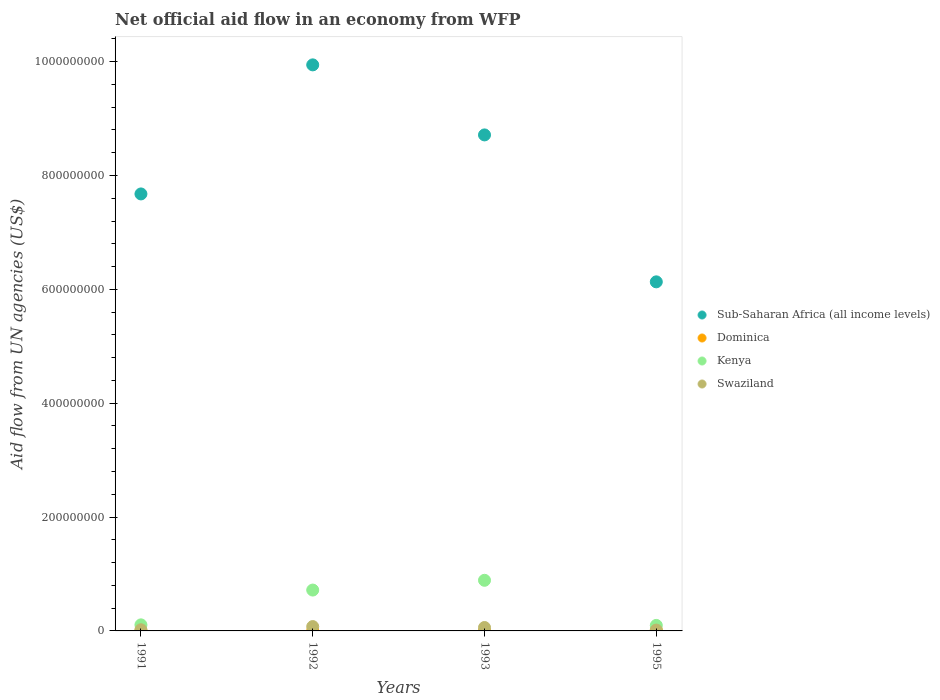How many different coloured dotlines are there?
Your response must be concise. 4. What is the net official aid flow in Dominica in 1993?
Your response must be concise. 2.20e+05. Across all years, what is the maximum net official aid flow in Swaziland?
Keep it short and to the point. 7.62e+06. Across all years, what is the minimum net official aid flow in Dominica?
Your response must be concise. 2.10e+05. In which year was the net official aid flow in Dominica maximum?
Provide a succinct answer. 1995. What is the total net official aid flow in Dominica in the graph?
Keep it short and to the point. 2.00e+06. What is the difference between the net official aid flow in Swaziland in 1992 and that in 1995?
Ensure brevity in your answer.  6.12e+06. What is the difference between the net official aid flow in Kenya in 1993 and the net official aid flow in Dominica in 1991?
Keep it short and to the point. 8.86e+07. What is the average net official aid flow in Swaziland per year?
Provide a succinct answer. 4.29e+06. In the year 1995, what is the difference between the net official aid flow in Sub-Saharan Africa (all income levels) and net official aid flow in Kenya?
Give a very brief answer. 6.03e+08. In how many years, is the net official aid flow in Dominica greater than 400000000 US$?
Your response must be concise. 0. What is the ratio of the net official aid flow in Sub-Saharan Africa (all income levels) in 1991 to that in 1992?
Offer a terse response. 0.77. What is the difference between the highest and the second highest net official aid flow in Dominica?
Your answer should be very brief. 1.01e+06. What is the difference between the highest and the lowest net official aid flow in Sub-Saharan Africa (all income levels)?
Provide a short and direct response. 3.81e+08. In how many years, is the net official aid flow in Kenya greater than the average net official aid flow in Kenya taken over all years?
Your answer should be very brief. 2. Is it the case that in every year, the sum of the net official aid flow in Dominica and net official aid flow in Sub-Saharan Africa (all income levels)  is greater than the sum of net official aid flow in Swaziland and net official aid flow in Kenya?
Offer a terse response. Yes. Is the net official aid flow in Dominica strictly greater than the net official aid flow in Sub-Saharan Africa (all income levels) over the years?
Offer a terse response. No. Is the net official aid flow in Sub-Saharan Africa (all income levels) strictly less than the net official aid flow in Swaziland over the years?
Provide a short and direct response. No. How many dotlines are there?
Give a very brief answer. 4. Does the graph contain any zero values?
Provide a succinct answer. No. How are the legend labels stacked?
Ensure brevity in your answer.  Vertical. What is the title of the graph?
Provide a succinct answer. Net official aid flow in an economy from WFP. What is the label or title of the Y-axis?
Offer a terse response. Aid flow from UN agencies (US$). What is the Aid flow from UN agencies (US$) in Sub-Saharan Africa (all income levels) in 1991?
Your answer should be compact. 7.68e+08. What is the Aid flow from UN agencies (US$) in Kenya in 1991?
Ensure brevity in your answer.  1.06e+07. What is the Aid flow from UN agencies (US$) of Swaziland in 1991?
Your response must be concise. 2.06e+06. What is the Aid flow from UN agencies (US$) in Sub-Saharan Africa (all income levels) in 1992?
Your answer should be compact. 9.94e+08. What is the Aid flow from UN agencies (US$) in Kenya in 1992?
Provide a short and direct response. 7.18e+07. What is the Aid flow from UN agencies (US$) of Swaziland in 1992?
Your answer should be compact. 7.62e+06. What is the Aid flow from UN agencies (US$) of Sub-Saharan Africa (all income levels) in 1993?
Your response must be concise. 8.71e+08. What is the Aid flow from UN agencies (US$) of Dominica in 1993?
Provide a short and direct response. 2.20e+05. What is the Aid flow from UN agencies (US$) of Kenya in 1993?
Keep it short and to the point. 8.89e+07. What is the Aid flow from UN agencies (US$) in Swaziland in 1993?
Ensure brevity in your answer.  5.99e+06. What is the Aid flow from UN agencies (US$) of Sub-Saharan Africa (all income levels) in 1995?
Provide a short and direct response. 6.13e+08. What is the Aid flow from UN agencies (US$) in Dominica in 1995?
Provide a succinct answer. 1.29e+06. What is the Aid flow from UN agencies (US$) in Kenya in 1995?
Keep it short and to the point. 9.68e+06. What is the Aid flow from UN agencies (US$) in Swaziland in 1995?
Your answer should be very brief. 1.50e+06. Across all years, what is the maximum Aid flow from UN agencies (US$) of Sub-Saharan Africa (all income levels)?
Keep it short and to the point. 9.94e+08. Across all years, what is the maximum Aid flow from UN agencies (US$) in Dominica?
Ensure brevity in your answer.  1.29e+06. Across all years, what is the maximum Aid flow from UN agencies (US$) in Kenya?
Offer a very short reply. 8.89e+07. Across all years, what is the maximum Aid flow from UN agencies (US$) of Swaziland?
Provide a succinct answer. 7.62e+06. Across all years, what is the minimum Aid flow from UN agencies (US$) of Sub-Saharan Africa (all income levels)?
Make the answer very short. 6.13e+08. Across all years, what is the minimum Aid flow from UN agencies (US$) of Dominica?
Give a very brief answer. 2.10e+05. Across all years, what is the minimum Aid flow from UN agencies (US$) in Kenya?
Your answer should be compact. 9.68e+06. Across all years, what is the minimum Aid flow from UN agencies (US$) in Swaziland?
Offer a very short reply. 1.50e+06. What is the total Aid flow from UN agencies (US$) in Sub-Saharan Africa (all income levels) in the graph?
Your answer should be very brief. 3.25e+09. What is the total Aid flow from UN agencies (US$) in Dominica in the graph?
Offer a terse response. 2.00e+06. What is the total Aid flow from UN agencies (US$) in Kenya in the graph?
Offer a terse response. 1.81e+08. What is the total Aid flow from UN agencies (US$) in Swaziland in the graph?
Give a very brief answer. 1.72e+07. What is the difference between the Aid flow from UN agencies (US$) of Sub-Saharan Africa (all income levels) in 1991 and that in 1992?
Your answer should be compact. -2.27e+08. What is the difference between the Aid flow from UN agencies (US$) of Dominica in 1991 and that in 1992?
Keep it short and to the point. 7.00e+04. What is the difference between the Aid flow from UN agencies (US$) of Kenya in 1991 and that in 1992?
Make the answer very short. -6.11e+07. What is the difference between the Aid flow from UN agencies (US$) in Swaziland in 1991 and that in 1992?
Your response must be concise. -5.56e+06. What is the difference between the Aid flow from UN agencies (US$) in Sub-Saharan Africa (all income levels) in 1991 and that in 1993?
Your answer should be compact. -1.04e+08. What is the difference between the Aid flow from UN agencies (US$) in Dominica in 1991 and that in 1993?
Provide a succinct answer. 6.00e+04. What is the difference between the Aid flow from UN agencies (US$) in Kenya in 1991 and that in 1993?
Offer a terse response. -7.83e+07. What is the difference between the Aid flow from UN agencies (US$) of Swaziland in 1991 and that in 1993?
Offer a terse response. -3.93e+06. What is the difference between the Aid flow from UN agencies (US$) of Sub-Saharan Africa (all income levels) in 1991 and that in 1995?
Give a very brief answer. 1.54e+08. What is the difference between the Aid flow from UN agencies (US$) of Dominica in 1991 and that in 1995?
Offer a terse response. -1.01e+06. What is the difference between the Aid flow from UN agencies (US$) in Kenya in 1991 and that in 1995?
Offer a very short reply. 9.60e+05. What is the difference between the Aid flow from UN agencies (US$) in Swaziland in 1991 and that in 1995?
Provide a succinct answer. 5.60e+05. What is the difference between the Aid flow from UN agencies (US$) in Sub-Saharan Africa (all income levels) in 1992 and that in 1993?
Ensure brevity in your answer.  1.23e+08. What is the difference between the Aid flow from UN agencies (US$) of Dominica in 1992 and that in 1993?
Your answer should be very brief. -10000. What is the difference between the Aid flow from UN agencies (US$) in Kenya in 1992 and that in 1993?
Your response must be concise. -1.72e+07. What is the difference between the Aid flow from UN agencies (US$) of Swaziland in 1992 and that in 1993?
Ensure brevity in your answer.  1.63e+06. What is the difference between the Aid flow from UN agencies (US$) of Sub-Saharan Africa (all income levels) in 1992 and that in 1995?
Your answer should be very brief. 3.81e+08. What is the difference between the Aid flow from UN agencies (US$) of Dominica in 1992 and that in 1995?
Give a very brief answer. -1.08e+06. What is the difference between the Aid flow from UN agencies (US$) in Kenya in 1992 and that in 1995?
Offer a terse response. 6.21e+07. What is the difference between the Aid flow from UN agencies (US$) in Swaziland in 1992 and that in 1995?
Offer a terse response. 6.12e+06. What is the difference between the Aid flow from UN agencies (US$) of Sub-Saharan Africa (all income levels) in 1993 and that in 1995?
Provide a short and direct response. 2.58e+08. What is the difference between the Aid flow from UN agencies (US$) of Dominica in 1993 and that in 1995?
Ensure brevity in your answer.  -1.07e+06. What is the difference between the Aid flow from UN agencies (US$) of Kenya in 1993 and that in 1995?
Keep it short and to the point. 7.92e+07. What is the difference between the Aid flow from UN agencies (US$) of Swaziland in 1993 and that in 1995?
Your answer should be very brief. 4.49e+06. What is the difference between the Aid flow from UN agencies (US$) in Sub-Saharan Africa (all income levels) in 1991 and the Aid flow from UN agencies (US$) in Dominica in 1992?
Make the answer very short. 7.67e+08. What is the difference between the Aid flow from UN agencies (US$) of Sub-Saharan Africa (all income levels) in 1991 and the Aid flow from UN agencies (US$) of Kenya in 1992?
Offer a very short reply. 6.96e+08. What is the difference between the Aid flow from UN agencies (US$) in Sub-Saharan Africa (all income levels) in 1991 and the Aid flow from UN agencies (US$) in Swaziland in 1992?
Make the answer very short. 7.60e+08. What is the difference between the Aid flow from UN agencies (US$) in Dominica in 1991 and the Aid flow from UN agencies (US$) in Kenya in 1992?
Your response must be concise. -7.15e+07. What is the difference between the Aid flow from UN agencies (US$) of Dominica in 1991 and the Aid flow from UN agencies (US$) of Swaziland in 1992?
Make the answer very short. -7.34e+06. What is the difference between the Aid flow from UN agencies (US$) of Kenya in 1991 and the Aid flow from UN agencies (US$) of Swaziland in 1992?
Offer a terse response. 3.02e+06. What is the difference between the Aid flow from UN agencies (US$) of Sub-Saharan Africa (all income levels) in 1991 and the Aid flow from UN agencies (US$) of Dominica in 1993?
Provide a succinct answer. 7.67e+08. What is the difference between the Aid flow from UN agencies (US$) of Sub-Saharan Africa (all income levels) in 1991 and the Aid flow from UN agencies (US$) of Kenya in 1993?
Your response must be concise. 6.79e+08. What is the difference between the Aid flow from UN agencies (US$) in Sub-Saharan Africa (all income levels) in 1991 and the Aid flow from UN agencies (US$) in Swaziland in 1993?
Ensure brevity in your answer.  7.62e+08. What is the difference between the Aid flow from UN agencies (US$) in Dominica in 1991 and the Aid flow from UN agencies (US$) in Kenya in 1993?
Your answer should be compact. -8.86e+07. What is the difference between the Aid flow from UN agencies (US$) in Dominica in 1991 and the Aid flow from UN agencies (US$) in Swaziland in 1993?
Keep it short and to the point. -5.71e+06. What is the difference between the Aid flow from UN agencies (US$) in Kenya in 1991 and the Aid flow from UN agencies (US$) in Swaziland in 1993?
Provide a succinct answer. 4.65e+06. What is the difference between the Aid flow from UN agencies (US$) of Sub-Saharan Africa (all income levels) in 1991 and the Aid flow from UN agencies (US$) of Dominica in 1995?
Make the answer very short. 7.66e+08. What is the difference between the Aid flow from UN agencies (US$) of Sub-Saharan Africa (all income levels) in 1991 and the Aid flow from UN agencies (US$) of Kenya in 1995?
Ensure brevity in your answer.  7.58e+08. What is the difference between the Aid flow from UN agencies (US$) in Sub-Saharan Africa (all income levels) in 1991 and the Aid flow from UN agencies (US$) in Swaziland in 1995?
Make the answer very short. 7.66e+08. What is the difference between the Aid flow from UN agencies (US$) of Dominica in 1991 and the Aid flow from UN agencies (US$) of Kenya in 1995?
Your response must be concise. -9.40e+06. What is the difference between the Aid flow from UN agencies (US$) of Dominica in 1991 and the Aid flow from UN agencies (US$) of Swaziland in 1995?
Provide a short and direct response. -1.22e+06. What is the difference between the Aid flow from UN agencies (US$) in Kenya in 1991 and the Aid flow from UN agencies (US$) in Swaziland in 1995?
Provide a succinct answer. 9.14e+06. What is the difference between the Aid flow from UN agencies (US$) of Sub-Saharan Africa (all income levels) in 1992 and the Aid flow from UN agencies (US$) of Dominica in 1993?
Your response must be concise. 9.94e+08. What is the difference between the Aid flow from UN agencies (US$) of Sub-Saharan Africa (all income levels) in 1992 and the Aid flow from UN agencies (US$) of Kenya in 1993?
Your answer should be very brief. 9.05e+08. What is the difference between the Aid flow from UN agencies (US$) in Sub-Saharan Africa (all income levels) in 1992 and the Aid flow from UN agencies (US$) in Swaziland in 1993?
Your answer should be compact. 9.88e+08. What is the difference between the Aid flow from UN agencies (US$) of Dominica in 1992 and the Aid flow from UN agencies (US$) of Kenya in 1993?
Your response must be concise. -8.87e+07. What is the difference between the Aid flow from UN agencies (US$) in Dominica in 1992 and the Aid flow from UN agencies (US$) in Swaziland in 1993?
Your answer should be very brief. -5.78e+06. What is the difference between the Aid flow from UN agencies (US$) in Kenya in 1992 and the Aid flow from UN agencies (US$) in Swaziland in 1993?
Your response must be concise. 6.58e+07. What is the difference between the Aid flow from UN agencies (US$) of Sub-Saharan Africa (all income levels) in 1992 and the Aid flow from UN agencies (US$) of Dominica in 1995?
Your answer should be very brief. 9.93e+08. What is the difference between the Aid flow from UN agencies (US$) in Sub-Saharan Africa (all income levels) in 1992 and the Aid flow from UN agencies (US$) in Kenya in 1995?
Offer a very short reply. 9.85e+08. What is the difference between the Aid flow from UN agencies (US$) in Sub-Saharan Africa (all income levels) in 1992 and the Aid flow from UN agencies (US$) in Swaziland in 1995?
Provide a succinct answer. 9.93e+08. What is the difference between the Aid flow from UN agencies (US$) in Dominica in 1992 and the Aid flow from UN agencies (US$) in Kenya in 1995?
Your answer should be very brief. -9.47e+06. What is the difference between the Aid flow from UN agencies (US$) in Dominica in 1992 and the Aid flow from UN agencies (US$) in Swaziland in 1995?
Provide a short and direct response. -1.29e+06. What is the difference between the Aid flow from UN agencies (US$) of Kenya in 1992 and the Aid flow from UN agencies (US$) of Swaziland in 1995?
Your response must be concise. 7.03e+07. What is the difference between the Aid flow from UN agencies (US$) in Sub-Saharan Africa (all income levels) in 1993 and the Aid flow from UN agencies (US$) in Dominica in 1995?
Offer a very short reply. 8.70e+08. What is the difference between the Aid flow from UN agencies (US$) of Sub-Saharan Africa (all income levels) in 1993 and the Aid flow from UN agencies (US$) of Kenya in 1995?
Your answer should be compact. 8.62e+08. What is the difference between the Aid flow from UN agencies (US$) in Sub-Saharan Africa (all income levels) in 1993 and the Aid flow from UN agencies (US$) in Swaziland in 1995?
Keep it short and to the point. 8.70e+08. What is the difference between the Aid flow from UN agencies (US$) in Dominica in 1993 and the Aid flow from UN agencies (US$) in Kenya in 1995?
Give a very brief answer. -9.46e+06. What is the difference between the Aid flow from UN agencies (US$) of Dominica in 1993 and the Aid flow from UN agencies (US$) of Swaziland in 1995?
Your answer should be very brief. -1.28e+06. What is the difference between the Aid flow from UN agencies (US$) in Kenya in 1993 and the Aid flow from UN agencies (US$) in Swaziland in 1995?
Your response must be concise. 8.74e+07. What is the average Aid flow from UN agencies (US$) of Sub-Saharan Africa (all income levels) per year?
Provide a short and direct response. 8.12e+08. What is the average Aid flow from UN agencies (US$) in Dominica per year?
Provide a succinct answer. 5.00e+05. What is the average Aid flow from UN agencies (US$) of Kenya per year?
Make the answer very short. 4.53e+07. What is the average Aid flow from UN agencies (US$) of Swaziland per year?
Offer a terse response. 4.29e+06. In the year 1991, what is the difference between the Aid flow from UN agencies (US$) of Sub-Saharan Africa (all income levels) and Aid flow from UN agencies (US$) of Dominica?
Make the answer very short. 7.67e+08. In the year 1991, what is the difference between the Aid flow from UN agencies (US$) in Sub-Saharan Africa (all income levels) and Aid flow from UN agencies (US$) in Kenya?
Provide a short and direct response. 7.57e+08. In the year 1991, what is the difference between the Aid flow from UN agencies (US$) of Sub-Saharan Africa (all income levels) and Aid flow from UN agencies (US$) of Swaziland?
Make the answer very short. 7.65e+08. In the year 1991, what is the difference between the Aid flow from UN agencies (US$) of Dominica and Aid flow from UN agencies (US$) of Kenya?
Make the answer very short. -1.04e+07. In the year 1991, what is the difference between the Aid flow from UN agencies (US$) of Dominica and Aid flow from UN agencies (US$) of Swaziland?
Provide a succinct answer. -1.78e+06. In the year 1991, what is the difference between the Aid flow from UN agencies (US$) of Kenya and Aid flow from UN agencies (US$) of Swaziland?
Offer a very short reply. 8.58e+06. In the year 1992, what is the difference between the Aid flow from UN agencies (US$) in Sub-Saharan Africa (all income levels) and Aid flow from UN agencies (US$) in Dominica?
Your answer should be very brief. 9.94e+08. In the year 1992, what is the difference between the Aid flow from UN agencies (US$) in Sub-Saharan Africa (all income levels) and Aid flow from UN agencies (US$) in Kenya?
Provide a succinct answer. 9.22e+08. In the year 1992, what is the difference between the Aid flow from UN agencies (US$) in Sub-Saharan Africa (all income levels) and Aid flow from UN agencies (US$) in Swaziland?
Provide a succinct answer. 9.87e+08. In the year 1992, what is the difference between the Aid flow from UN agencies (US$) of Dominica and Aid flow from UN agencies (US$) of Kenya?
Provide a short and direct response. -7.16e+07. In the year 1992, what is the difference between the Aid flow from UN agencies (US$) of Dominica and Aid flow from UN agencies (US$) of Swaziland?
Make the answer very short. -7.41e+06. In the year 1992, what is the difference between the Aid flow from UN agencies (US$) of Kenya and Aid flow from UN agencies (US$) of Swaziland?
Your answer should be compact. 6.42e+07. In the year 1993, what is the difference between the Aid flow from UN agencies (US$) in Sub-Saharan Africa (all income levels) and Aid flow from UN agencies (US$) in Dominica?
Your answer should be very brief. 8.71e+08. In the year 1993, what is the difference between the Aid flow from UN agencies (US$) in Sub-Saharan Africa (all income levels) and Aid flow from UN agencies (US$) in Kenya?
Offer a very short reply. 7.82e+08. In the year 1993, what is the difference between the Aid flow from UN agencies (US$) in Sub-Saharan Africa (all income levels) and Aid flow from UN agencies (US$) in Swaziland?
Your answer should be very brief. 8.65e+08. In the year 1993, what is the difference between the Aid flow from UN agencies (US$) in Dominica and Aid flow from UN agencies (US$) in Kenya?
Make the answer very short. -8.87e+07. In the year 1993, what is the difference between the Aid flow from UN agencies (US$) of Dominica and Aid flow from UN agencies (US$) of Swaziland?
Ensure brevity in your answer.  -5.77e+06. In the year 1993, what is the difference between the Aid flow from UN agencies (US$) in Kenya and Aid flow from UN agencies (US$) in Swaziland?
Give a very brief answer. 8.29e+07. In the year 1995, what is the difference between the Aid flow from UN agencies (US$) in Sub-Saharan Africa (all income levels) and Aid flow from UN agencies (US$) in Dominica?
Give a very brief answer. 6.12e+08. In the year 1995, what is the difference between the Aid flow from UN agencies (US$) of Sub-Saharan Africa (all income levels) and Aid flow from UN agencies (US$) of Kenya?
Offer a terse response. 6.03e+08. In the year 1995, what is the difference between the Aid flow from UN agencies (US$) of Sub-Saharan Africa (all income levels) and Aid flow from UN agencies (US$) of Swaziland?
Your answer should be compact. 6.12e+08. In the year 1995, what is the difference between the Aid flow from UN agencies (US$) in Dominica and Aid flow from UN agencies (US$) in Kenya?
Offer a terse response. -8.39e+06. In the year 1995, what is the difference between the Aid flow from UN agencies (US$) in Dominica and Aid flow from UN agencies (US$) in Swaziland?
Provide a succinct answer. -2.10e+05. In the year 1995, what is the difference between the Aid flow from UN agencies (US$) of Kenya and Aid flow from UN agencies (US$) of Swaziland?
Ensure brevity in your answer.  8.18e+06. What is the ratio of the Aid flow from UN agencies (US$) in Sub-Saharan Africa (all income levels) in 1991 to that in 1992?
Ensure brevity in your answer.  0.77. What is the ratio of the Aid flow from UN agencies (US$) of Dominica in 1991 to that in 1992?
Make the answer very short. 1.33. What is the ratio of the Aid flow from UN agencies (US$) of Kenya in 1991 to that in 1992?
Ensure brevity in your answer.  0.15. What is the ratio of the Aid flow from UN agencies (US$) of Swaziland in 1991 to that in 1992?
Your response must be concise. 0.27. What is the ratio of the Aid flow from UN agencies (US$) of Sub-Saharan Africa (all income levels) in 1991 to that in 1993?
Your answer should be very brief. 0.88. What is the ratio of the Aid flow from UN agencies (US$) in Dominica in 1991 to that in 1993?
Your answer should be compact. 1.27. What is the ratio of the Aid flow from UN agencies (US$) of Kenya in 1991 to that in 1993?
Provide a short and direct response. 0.12. What is the ratio of the Aid flow from UN agencies (US$) in Swaziland in 1991 to that in 1993?
Provide a short and direct response. 0.34. What is the ratio of the Aid flow from UN agencies (US$) of Sub-Saharan Africa (all income levels) in 1991 to that in 1995?
Make the answer very short. 1.25. What is the ratio of the Aid flow from UN agencies (US$) in Dominica in 1991 to that in 1995?
Ensure brevity in your answer.  0.22. What is the ratio of the Aid flow from UN agencies (US$) of Kenya in 1991 to that in 1995?
Provide a short and direct response. 1.1. What is the ratio of the Aid flow from UN agencies (US$) in Swaziland in 1991 to that in 1995?
Your response must be concise. 1.37. What is the ratio of the Aid flow from UN agencies (US$) in Sub-Saharan Africa (all income levels) in 1992 to that in 1993?
Your response must be concise. 1.14. What is the ratio of the Aid flow from UN agencies (US$) in Dominica in 1992 to that in 1993?
Ensure brevity in your answer.  0.95. What is the ratio of the Aid flow from UN agencies (US$) in Kenya in 1992 to that in 1993?
Provide a short and direct response. 0.81. What is the ratio of the Aid flow from UN agencies (US$) in Swaziland in 1992 to that in 1993?
Keep it short and to the point. 1.27. What is the ratio of the Aid flow from UN agencies (US$) of Sub-Saharan Africa (all income levels) in 1992 to that in 1995?
Ensure brevity in your answer.  1.62. What is the ratio of the Aid flow from UN agencies (US$) in Dominica in 1992 to that in 1995?
Ensure brevity in your answer.  0.16. What is the ratio of the Aid flow from UN agencies (US$) of Kenya in 1992 to that in 1995?
Offer a very short reply. 7.41. What is the ratio of the Aid flow from UN agencies (US$) in Swaziland in 1992 to that in 1995?
Offer a very short reply. 5.08. What is the ratio of the Aid flow from UN agencies (US$) in Sub-Saharan Africa (all income levels) in 1993 to that in 1995?
Offer a very short reply. 1.42. What is the ratio of the Aid flow from UN agencies (US$) in Dominica in 1993 to that in 1995?
Provide a short and direct response. 0.17. What is the ratio of the Aid flow from UN agencies (US$) in Kenya in 1993 to that in 1995?
Keep it short and to the point. 9.19. What is the ratio of the Aid flow from UN agencies (US$) in Swaziland in 1993 to that in 1995?
Ensure brevity in your answer.  3.99. What is the difference between the highest and the second highest Aid flow from UN agencies (US$) of Sub-Saharan Africa (all income levels)?
Ensure brevity in your answer.  1.23e+08. What is the difference between the highest and the second highest Aid flow from UN agencies (US$) in Dominica?
Give a very brief answer. 1.01e+06. What is the difference between the highest and the second highest Aid flow from UN agencies (US$) of Kenya?
Keep it short and to the point. 1.72e+07. What is the difference between the highest and the second highest Aid flow from UN agencies (US$) in Swaziland?
Ensure brevity in your answer.  1.63e+06. What is the difference between the highest and the lowest Aid flow from UN agencies (US$) of Sub-Saharan Africa (all income levels)?
Give a very brief answer. 3.81e+08. What is the difference between the highest and the lowest Aid flow from UN agencies (US$) in Dominica?
Your answer should be very brief. 1.08e+06. What is the difference between the highest and the lowest Aid flow from UN agencies (US$) of Kenya?
Make the answer very short. 7.92e+07. What is the difference between the highest and the lowest Aid flow from UN agencies (US$) of Swaziland?
Provide a short and direct response. 6.12e+06. 